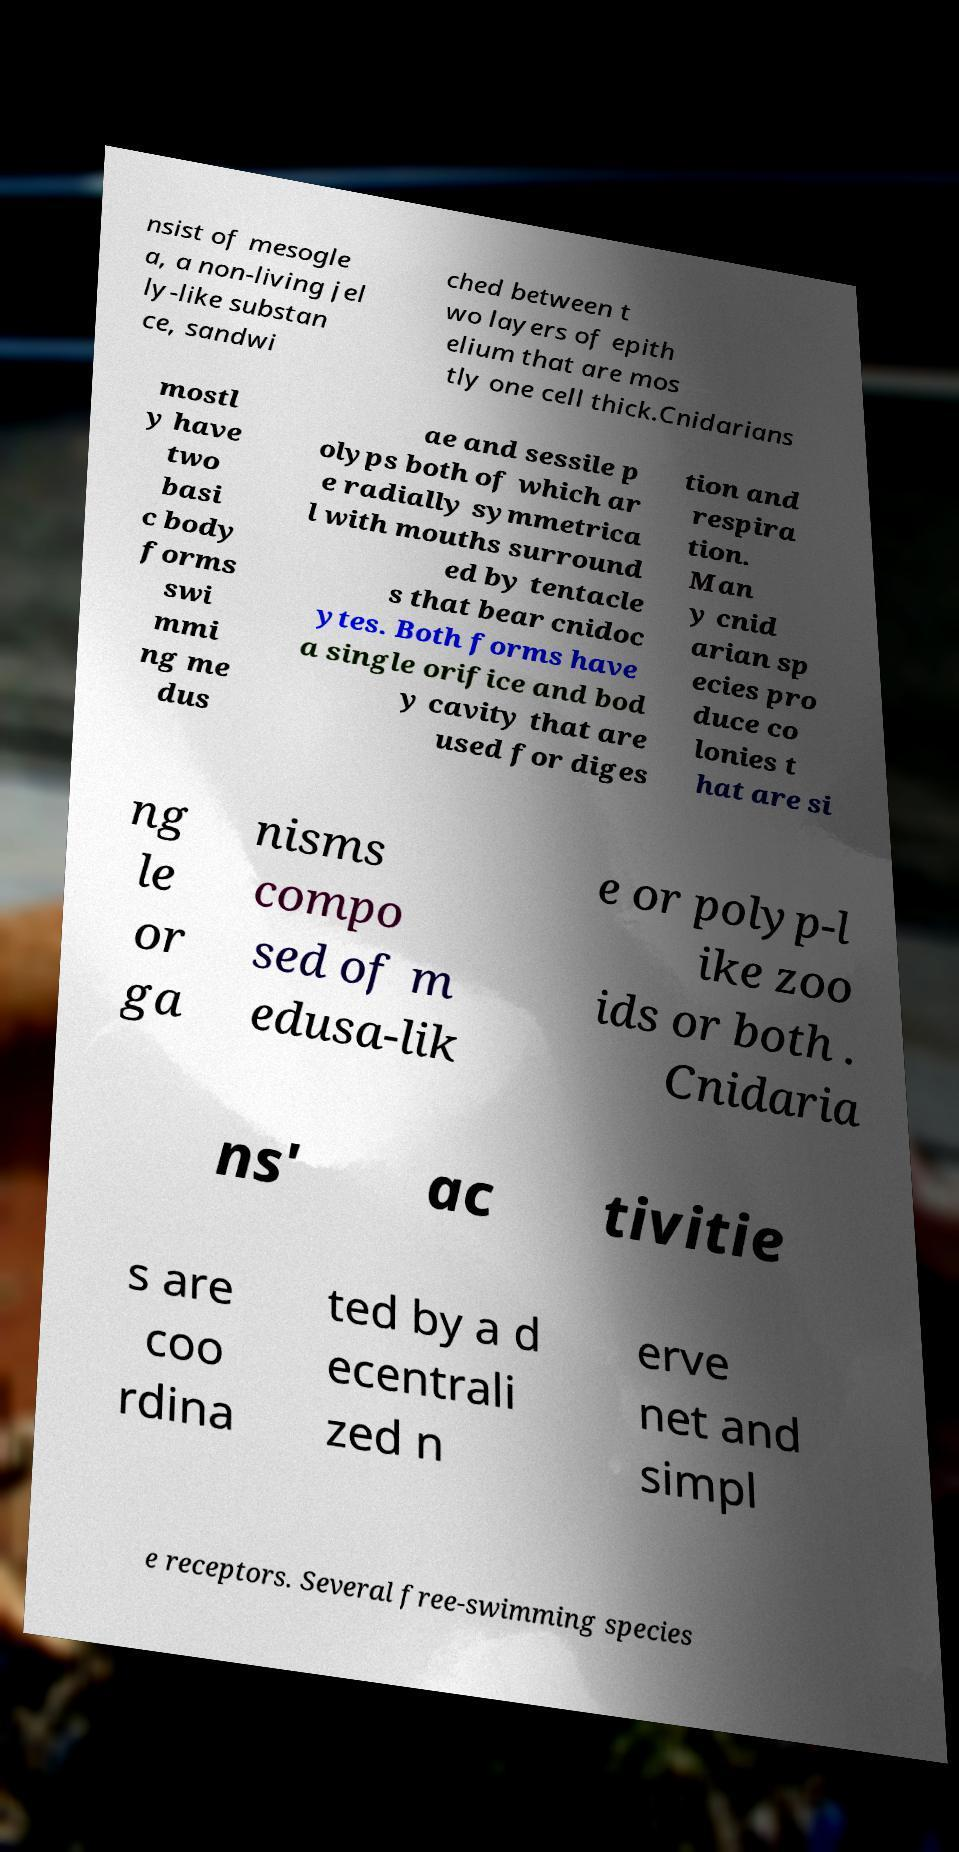Could you assist in decoding the text presented in this image and type it out clearly? nsist of mesogle a, a non-living jel ly-like substan ce, sandwi ched between t wo layers of epith elium that are mos tly one cell thick.Cnidarians mostl y have two basi c body forms swi mmi ng me dus ae and sessile p olyps both of which ar e radially symmetrica l with mouths surround ed by tentacle s that bear cnidoc ytes. Both forms have a single orifice and bod y cavity that are used for diges tion and respira tion. Man y cnid arian sp ecies pro duce co lonies t hat are si ng le or ga nisms compo sed of m edusa-lik e or polyp-l ike zoo ids or both . Cnidaria ns' ac tivitie s are coo rdina ted by a d ecentrali zed n erve net and simpl e receptors. Several free-swimming species 